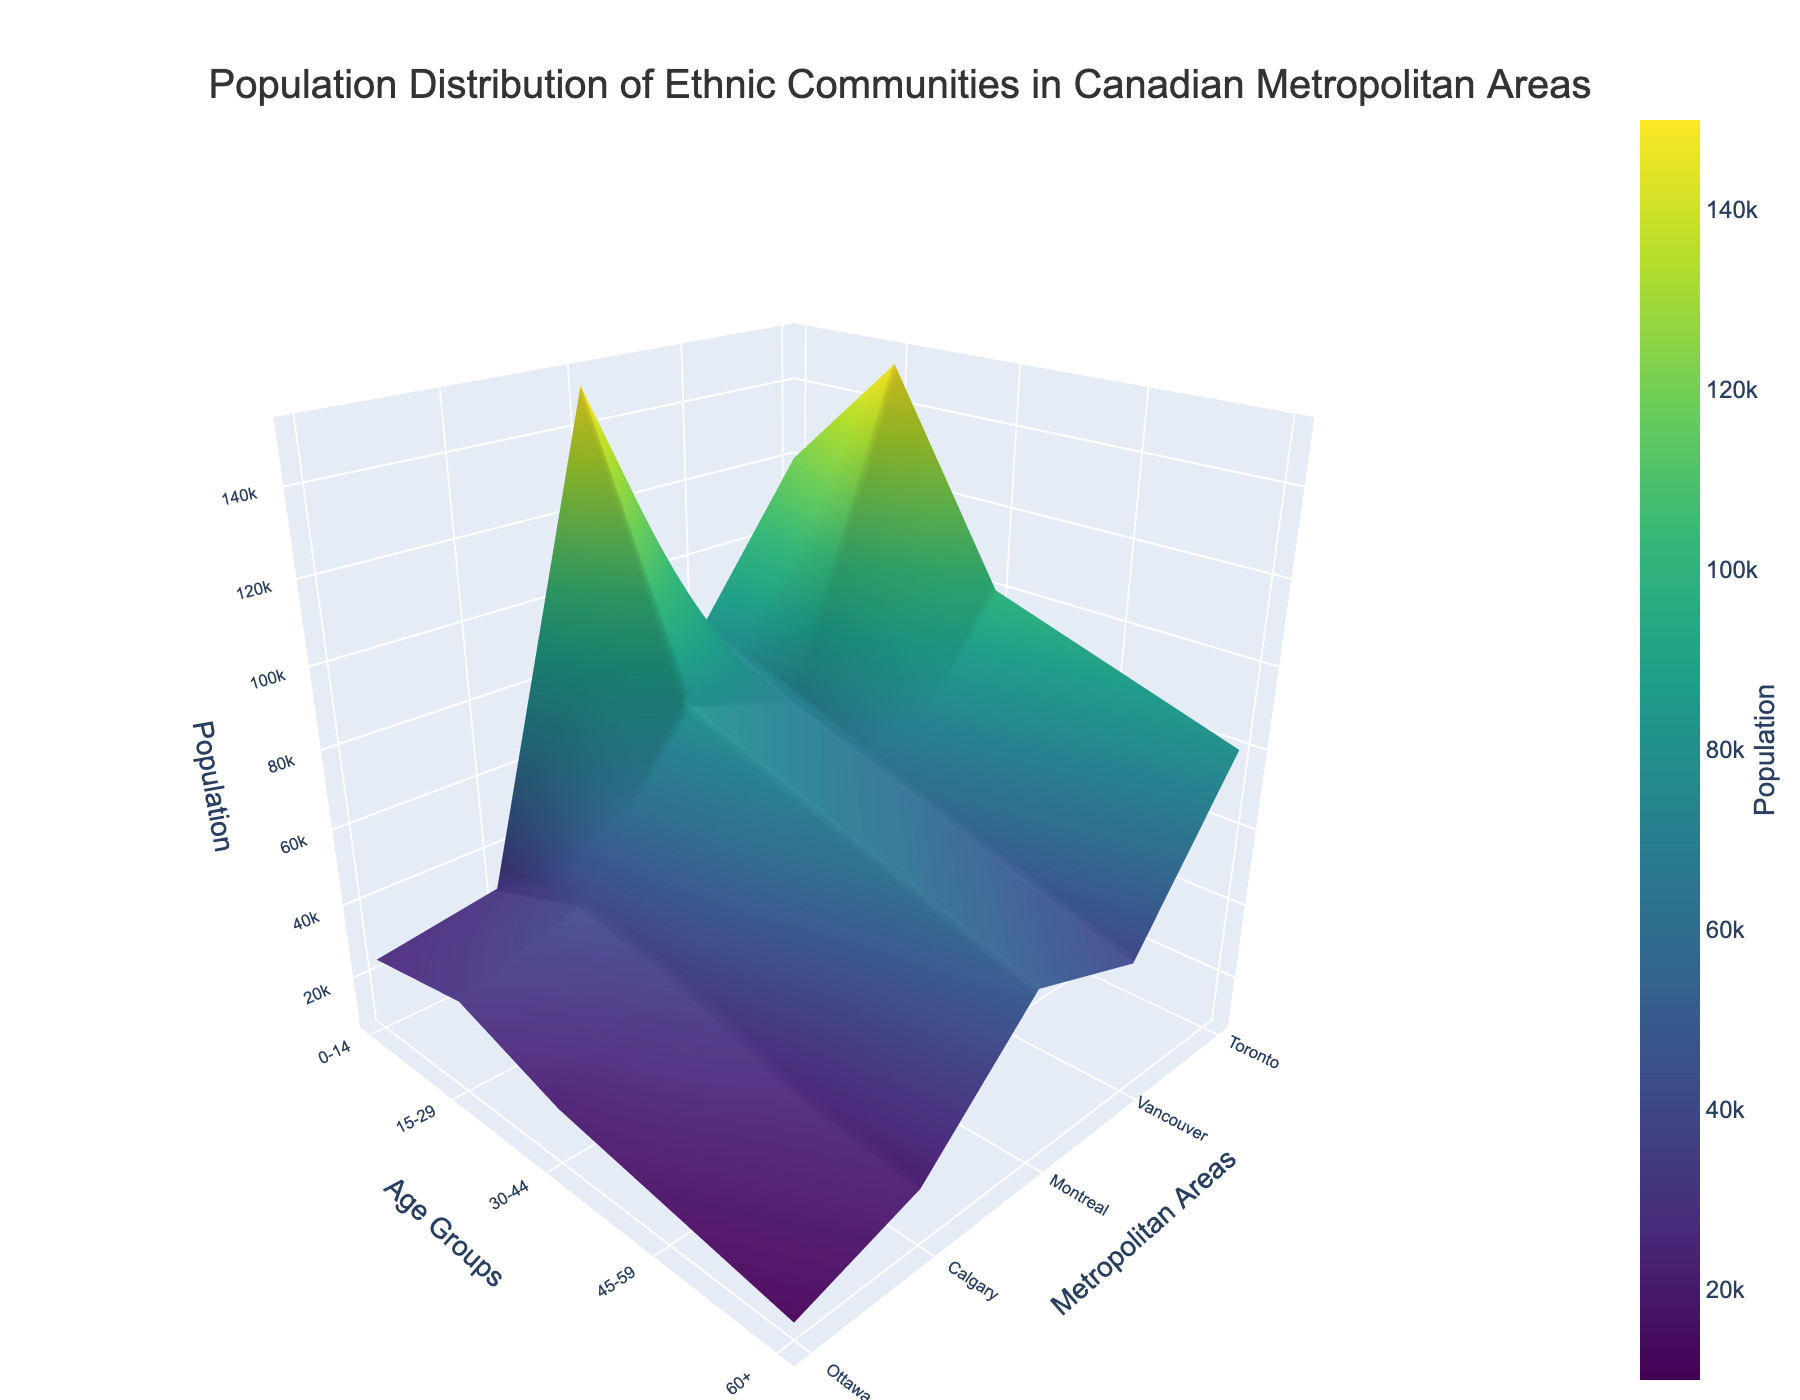What's the title of the figure? The title is located at the top center of the figure's layout. It should be clearly visible and is intended to summarize the content of the figure.
Answer: Population Distribution of Ethnic Communities in Canadian Metropolitan Areas Which city has the highest population in the 0-14 age group? Look at the part of the surface plot corresponding to the 0-14 age group, and identify which point has the highest Z value, which represents the population.
Answer: Montreal Which age group has the highest Chinese population in Toronto? Examine the sections under Toronto for each age group. Compare the surface heights to determine where the Z value for Chinese is the highest.
Answer: 15-29 Compare the South Asian population in Toronto and Calgary for the 15-29 age group. Which city has a larger population? Identify the height of the surface at the intersection of 'Toronto' and '15-29' for South Asian, and then do the same for Calgary and South Asian in the same age group. Compare these heights.
Answer: Toronto What is the total population of the 60+ age group across all cities? Sum the Z values (population data) for all cities for the 60+ age group. The Z values represent the populations for each ethnic community in the cities.
Answer: 180000 Which ethnic group has the largest population in Vancouver? Identify the peak values in the surface plot under 'Vancouver' for all age groups and use the legend/color scale to determine which ethnic group it represents.
Answer: Chinese What age group has the highest population in Montreal? Compare the Z values within each age group category for Montreal. The highest peak indicates the largest population.
Answer: 0-14 Is there any age group where the Lebanese population is the highest in any city? Examine the legend alongside the colors on the surface plot for each age group in all five cities. Check the Z values for Lebanese and see if any indicates the highest population.
Answer: No How does the population of the Italian community in Toronto compare to Montreal in the 45-59 age group? Look at the height of the surface plot for both Toronto and Montreal in the 45-59 age group under the 'Italian' category. Compare the values.
Answer: Toronto has a higher population Which city has the smallest population in the 60+ age group? Compare the surface heights representing the 60+ age group for each city, identifying which one has the lowest peak.
Answer: Ottawa 